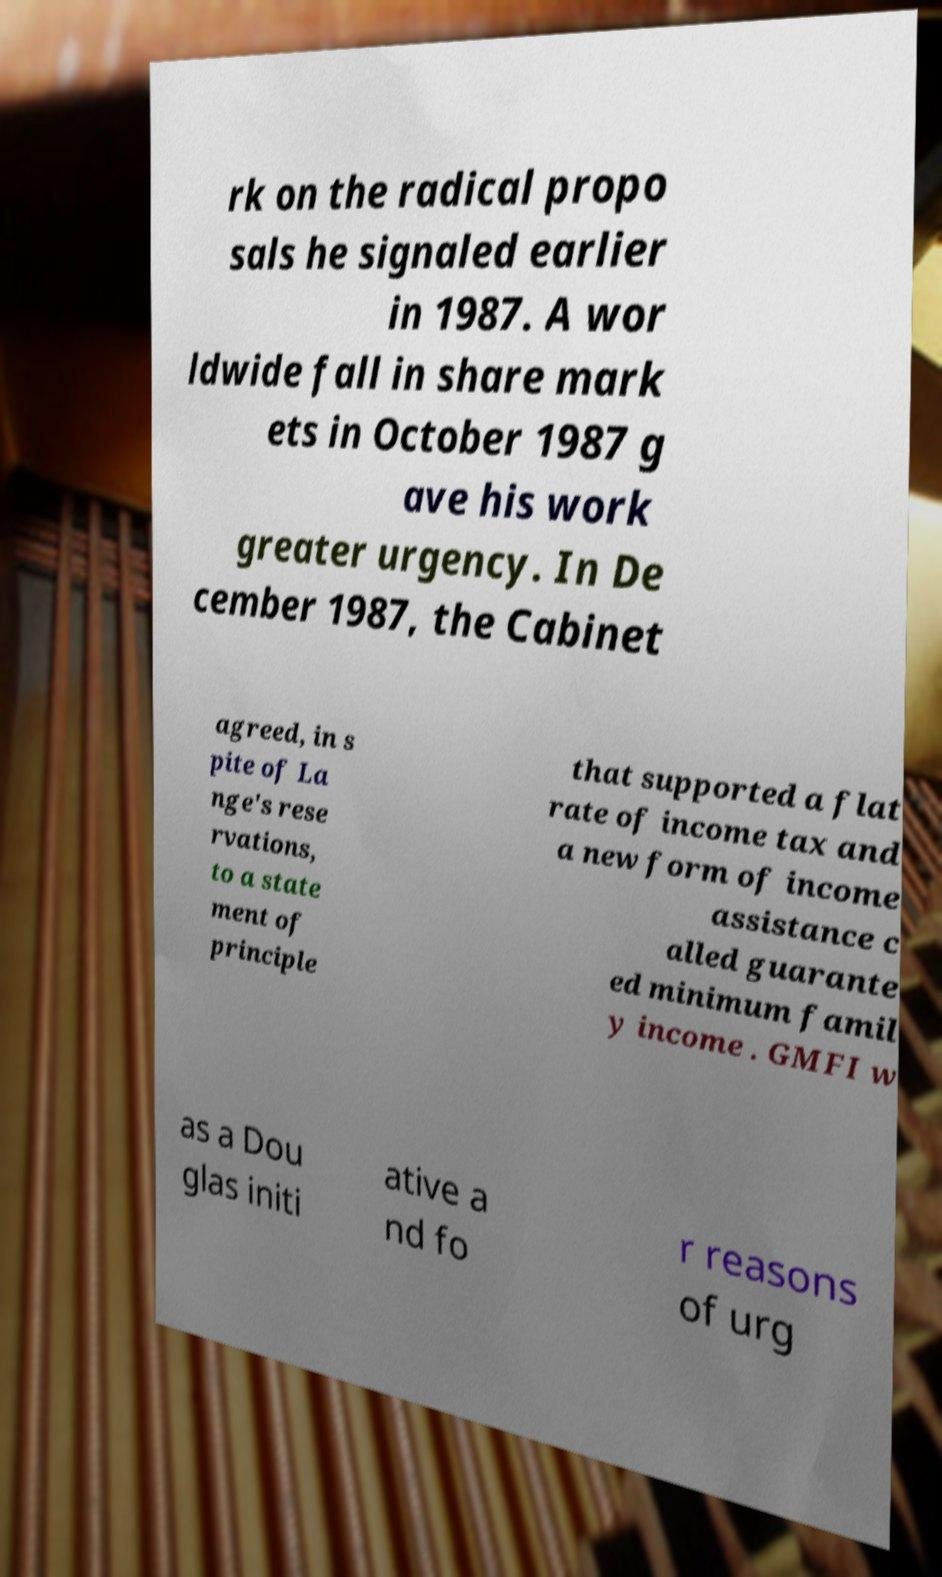Please identify and transcribe the text found in this image. rk on the radical propo sals he signaled earlier in 1987. A wor ldwide fall in share mark ets in October 1987 g ave his work greater urgency. In De cember 1987, the Cabinet agreed, in s pite of La nge's rese rvations, to a state ment of principle that supported a flat rate of income tax and a new form of income assistance c alled guarante ed minimum famil y income . GMFI w as a Dou glas initi ative a nd fo r reasons of urg 